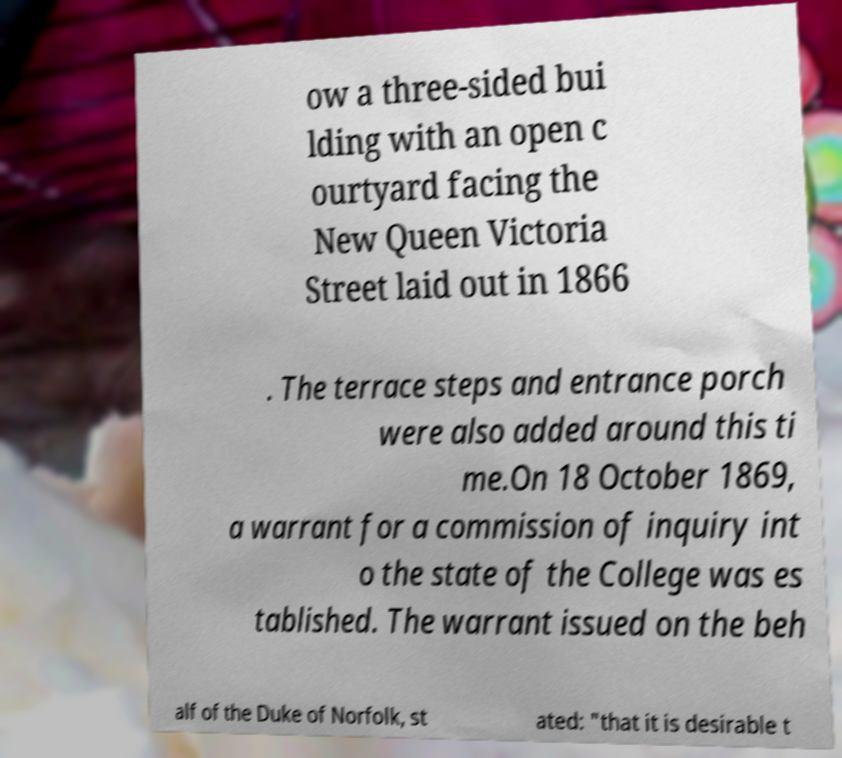I need the written content from this picture converted into text. Can you do that? ow a three-sided bui lding with an open c ourtyard facing the New Queen Victoria Street laid out in 1866 . The terrace steps and entrance porch were also added around this ti me.On 18 October 1869, a warrant for a commission of inquiry int o the state of the College was es tablished. The warrant issued on the beh alf of the Duke of Norfolk, st ated: "that it is desirable t 